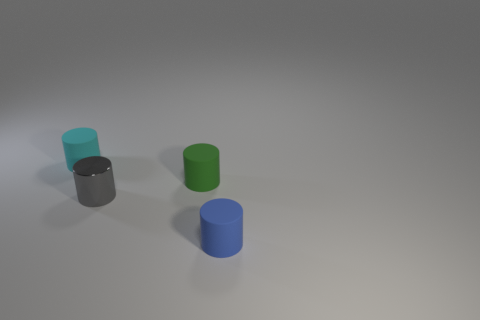Do the cylinders cast shadows, and if so, what does that tell us about the lighting? Yes, each cylinder casts a shadow, indicating that the light source is coming from the upper left side, given the direction of the shadows towards the lower right. This implies a single, possibly distant light source such as a sun or a spotlight. 